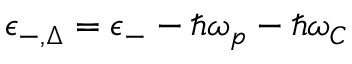<formula> <loc_0><loc_0><loc_500><loc_500>\epsilon _ { - , \Delta } = \epsilon _ { - } - \hbar { \omega } _ { p } - \hbar { \omega } _ { C }</formula> 